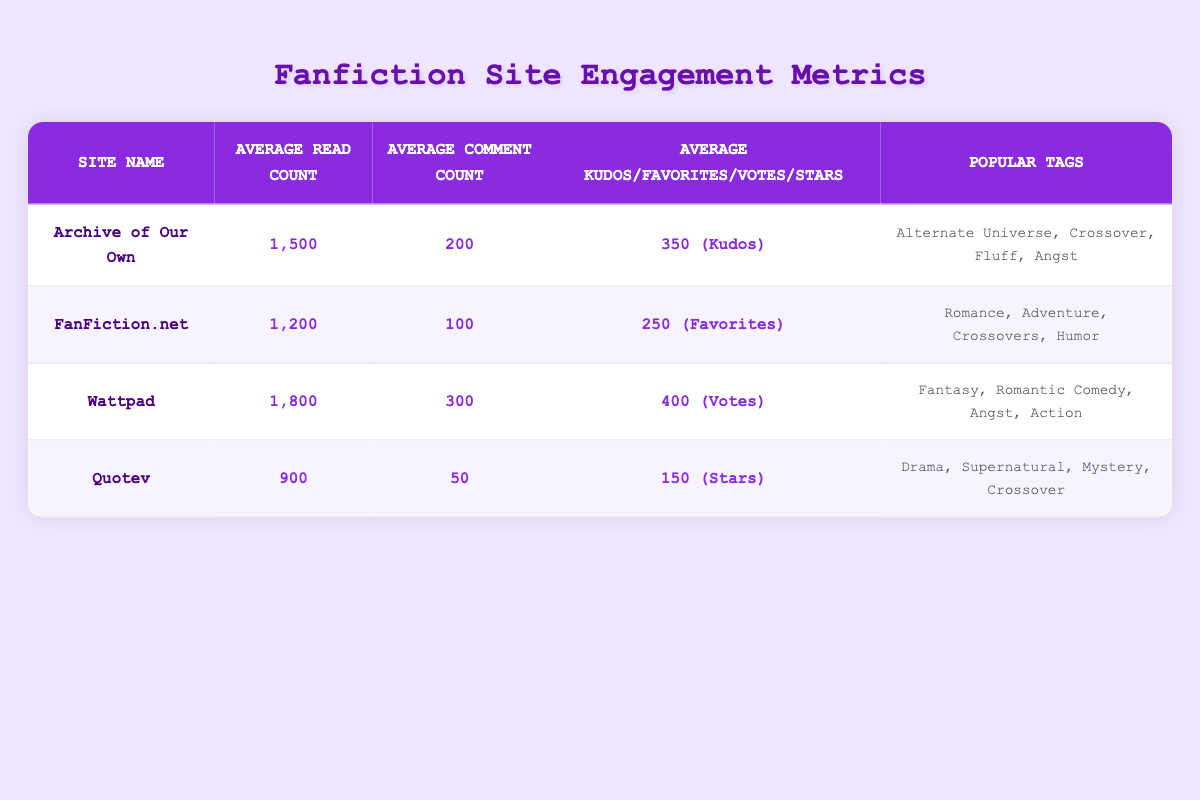What is the average read count for "Wattpad"? The average read count for "Wattpad" is provided directly in the table as 1800.
Answer: 1800 Which site has the highest average comment count? The table lists the average comment counts for different sites. "Wattpad" has the highest average comment count at 300.
Answer: Wattpad What are the popular tags associated with "Archive of Our Own"? The popular tags for "Archive of Our Own" are listed in the table as "Alternate Universe, Crossover, Fluff, Angst."
Answer: Alternate Universe, Crossover, Fluff, Angst What is the combined average read count of "FanFiction.net" and "Quotev"? The average read count for "FanFiction.net" is 1200, and for "Quotev" it is 900. The combined total is 1200 + 900 = 2100, so the average is 2100 / 2 = 1050.
Answer: 1050 Is the average votes count higher for "Wattpad" than the average kudos count for "Archive of Our Own"? The average votes count for "Wattpad" is 400, while the average kudos count for "Archive of Our Own" is 350. Since 400 is greater than 350, the statement is true.
Answer: Yes What is the average difference in read counts between "Wattpad" and "Quotev"? To find the average difference, subtract "Quotev's" read count (900) from "Wattpad's" read count (1800). The difference is 1800 - 900 = 900.
Answer: 900 Which site has fewer than 200 average comments? The only site listed with fewer than 200 average comments is "Quotev," which has an average comment count of 50.
Answer: Quotev What percentage of average reads does "FanFiction.net" have compared to "Wattpad"? The average read count for "FanFiction.net" is 1200 and for "Wattpad," it is 1800. To find the percentage, (1200 / 1800) * 100 gives approximately 66.67%.
Answer: 66.67% Are "Drama" and "Fantasy" popular tags in any of the listed sites? "Drama" is a popular tag for "Quotev," while "Fantasy" is a popular tag for "Wattpad." Therefore, both tags are popular across different sites.
Answer: Yes 